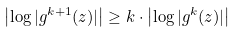Convert formula to latex. <formula><loc_0><loc_0><loc_500><loc_500>\left | \log | g ^ { k + 1 } ( z ) | \right | \geq k \cdot \left | \log | g ^ { k } ( z ) | \right |</formula> 